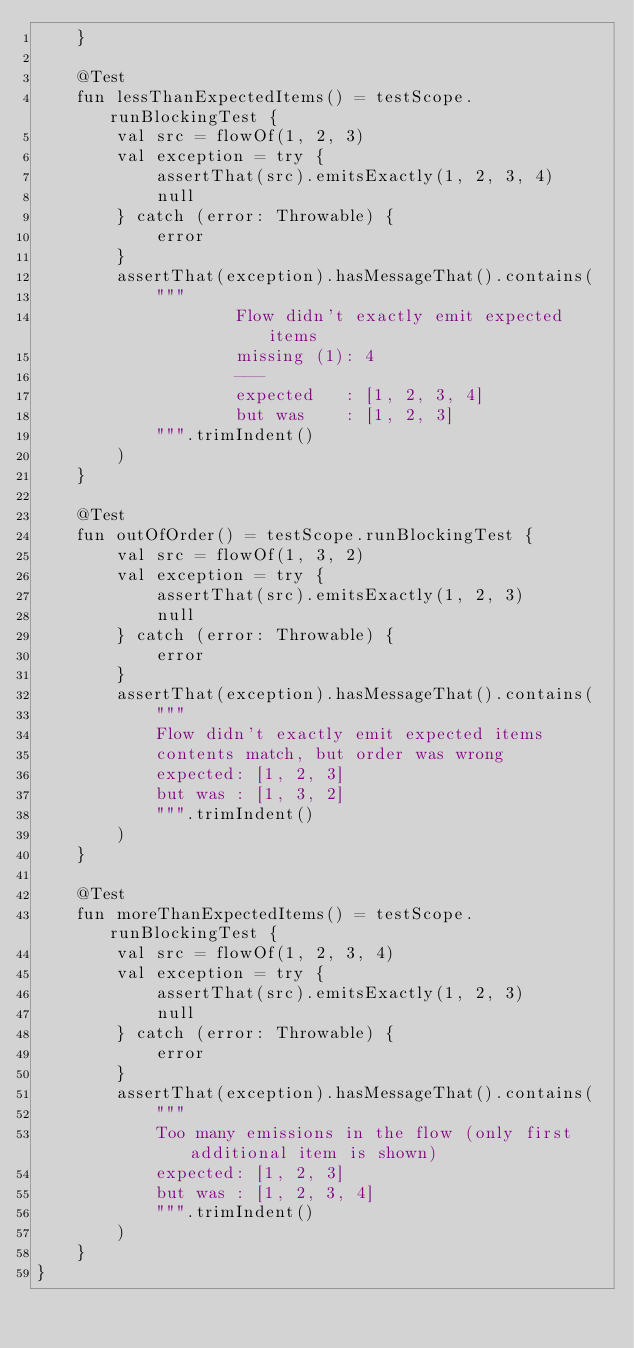Convert code to text. <code><loc_0><loc_0><loc_500><loc_500><_Kotlin_>    }

    @Test
    fun lessThanExpectedItems() = testScope.runBlockingTest {
        val src = flowOf(1, 2, 3)
        val exception = try {
            assertThat(src).emitsExactly(1, 2, 3, 4)
            null
        } catch (error: Throwable) {
            error
        }
        assertThat(exception).hasMessageThat().contains(
            """
                    Flow didn't exactly emit expected items
                    missing (1): 4
                    ---
                    expected   : [1, 2, 3, 4]
                    but was    : [1, 2, 3]
            """.trimIndent()
        )
    }

    @Test
    fun outOfOrder() = testScope.runBlockingTest {
        val src = flowOf(1, 3, 2)
        val exception = try {
            assertThat(src).emitsExactly(1, 2, 3)
            null
        } catch (error: Throwable) {
            error
        }
        assertThat(exception).hasMessageThat().contains(
            """
            Flow didn't exactly emit expected items
            contents match, but order was wrong
            expected: [1, 2, 3]
            but was : [1, 3, 2]
            """.trimIndent()
        )
    }

    @Test
    fun moreThanExpectedItems() = testScope.runBlockingTest {
        val src = flowOf(1, 2, 3, 4)
        val exception = try {
            assertThat(src).emitsExactly(1, 2, 3)
            null
        } catch (error: Throwable) {
            error
        }
        assertThat(exception).hasMessageThat().contains(
            """
            Too many emissions in the flow (only first additional item is shown)
            expected: [1, 2, 3]
            but was : [1, 2, 3, 4]
            """.trimIndent()
        )
    }
}
</code> 